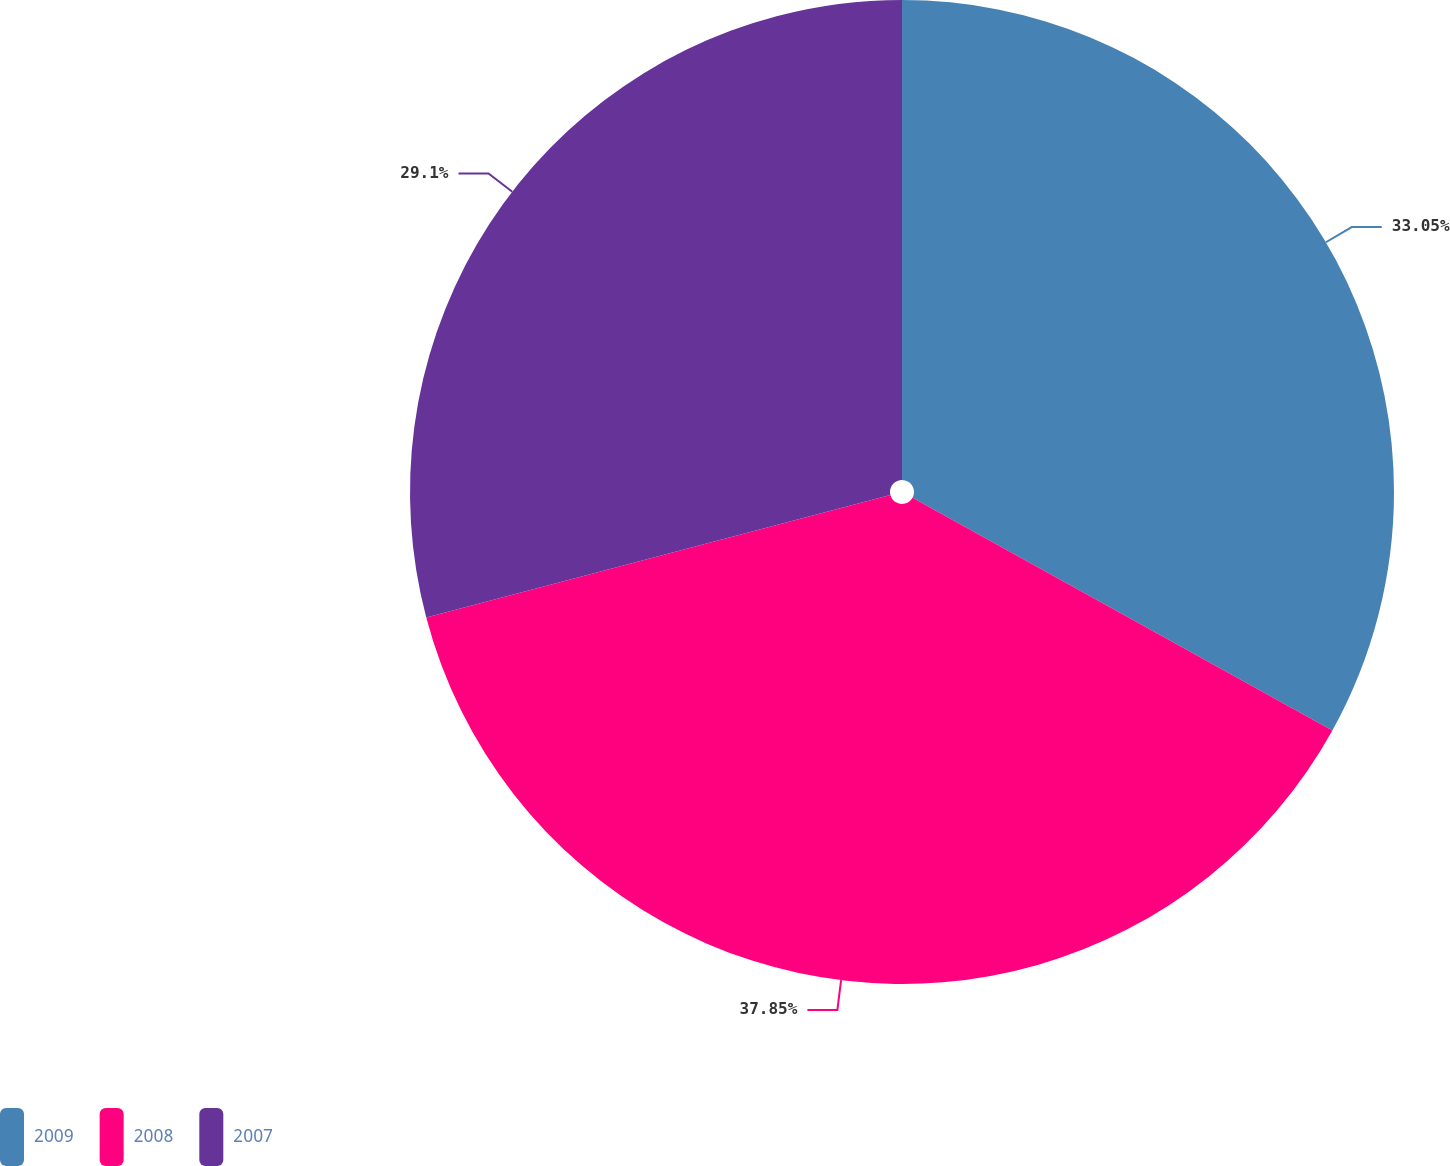<chart> <loc_0><loc_0><loc_500><loc_500><pie_chart><fcel>2009<fcel>2008<fcel>2007<nl><fcel>33.05%<fcel>37.84%<fcel>29.1%<nl></chart> 